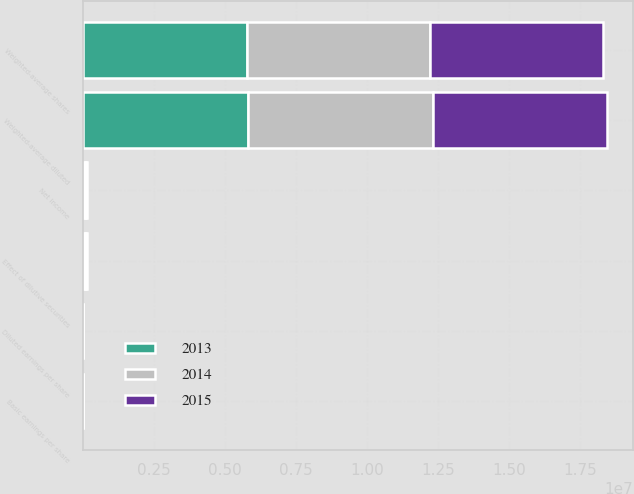<chart> <loc_0><loc_0><loc_500><loc_500><stacked_bar_chart><ecel><fcel>Net income<fcel>Weighted-average shares<fcel>Effect of dilutive securities<fcel>Weighted-average diluted<fcel>Basic earnings per share<fcel>Diluted earnings per share<nl><fcel>2013<fcel>53394<fcel>5.75342e+06<fcel>39648<fcel>5.79307e+06<fcel>9.28<fcel>9.22<nl><fcel>2015<fcel>39510<fcel>6.08557e+06<fcel>37091<fcel>6.12266e+06<fcel>6.49<fcel>6.45<nl><fcel>2014<fcel>37037<fcel>6.47732e+06<fcel>44314<fcel>6.52163e+06<fcel>5.72<fcel>5.68<nl></chart> 